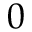<formula> <loc_0><loc_0><loc_500><loc_500>0</formula> 